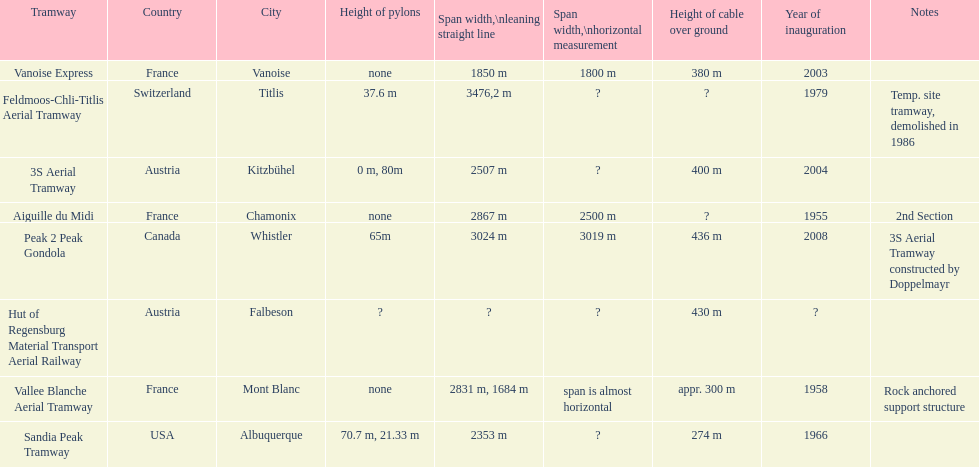Was the sandia peak tramway innagurate before or after the 3s aerial tramway? Before. 